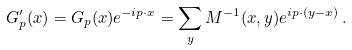<formula> <loc_0><loc_0><loc_500><loc_500>G ^ { \prime } _ { p } ( x ) = G _ { p } ( x ) e ^ { - i p \cdot x } = \sum _ { y } M ^ { - 1 } ( x , y ) e ^ { i p \cdot ( y - x ) } \, .</formula> 